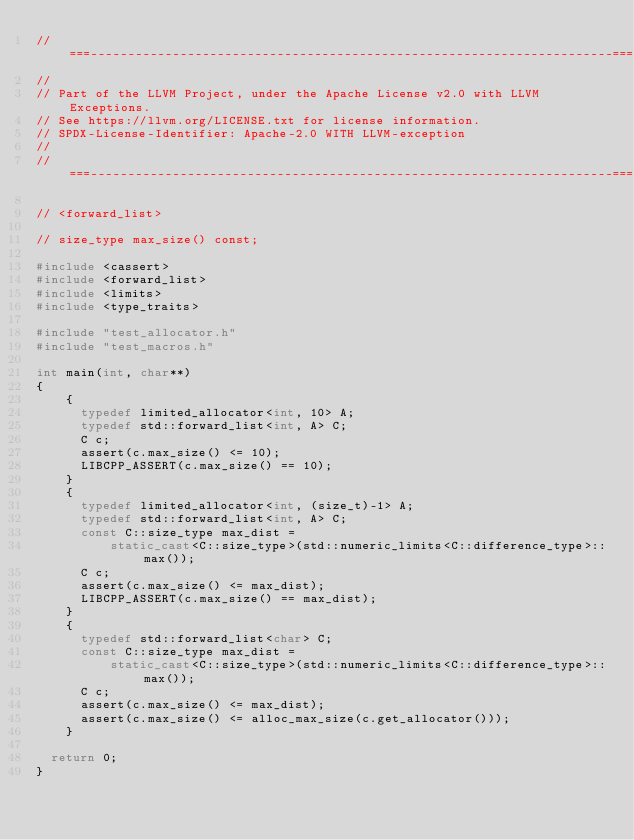Convert code to text. <code><loc_0><loc_0><loc_500><loc_500><_C++_>//===----------------------------------------------------------------------===//
//
// Part of the LLVM Project, under the Apache License v2.0 with LLVM Exceptions.
// See https://llvm.org/LICENSE.txt for license information.
// SPDX-License-Identifier: Apache-2.0 WITH LLVM-exception
//
//===----------------------------------------------------------------------===//

// <forward_list>

// size_type max_size() const;

#include <cassert>
#include <forward_list>
#include <limits>
#include <type_traits>

#include "test_allocator.h"
#include "test_macros.h"

int main(int, char**)
{
    {
      typedef limited_allocator<int, 10> A;
      typedef std::forward_list<int, A> C;
      C c;
      assert(c.max_size() <= 10);
      LIBCPP_ASSERT(c.max_size() == 10);
    }
    {
      typedef limited_allocator<int, (size_t)-1> A;
      typedef std::forward_list<int, A> C;
      const C::size_type max_dist =
          static_cast<C::size_type>(std::numeric_limits<C::difference_type>::max());
      C c;
      assert(c.max_size() <= max_dist);
      LIBCPP_ASSERT(c.max_size() == max_dist);
    }
    {
      typedef std::forward_list<char> C;
      const C::size_type max_dist =
          static_cast<C::size_type>(std::numeric_limits<C::difference_type>::max());
      C c;
      assert(c.max_size() <= max_dist);
      assert(c.max_size() <= alloc_max_size(c.get_allocator()));
    }

  return 0;
}
</code> 